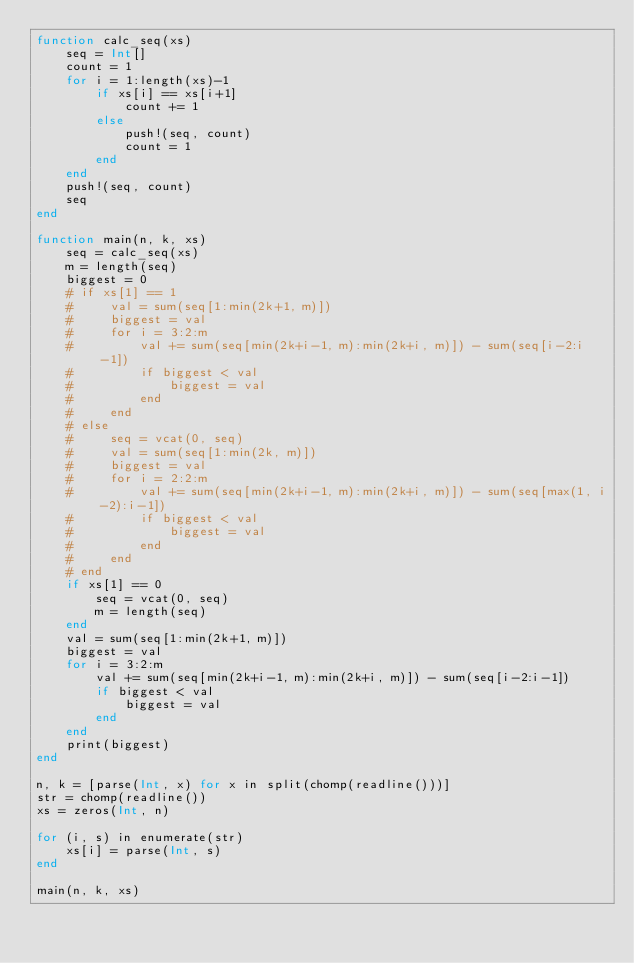Convert code to text. <code><loc_0><loc_0><loc_500><loc_500><_Julia_>function calc_seq(xs)
    seq = Int[]
    count = 1
    for i = 1:length(xs)-1
        if xs[i] == xs[i+1]
            count += 1
        else
            push!(seq, count)
            count = 1
        end
    end
    push!(seq, count)
    seq
end

function main(n, k, xs)
    seq = calc_seq(xs)
    m = length(seq)
    biggest = 0
    # if xs[1] == 1
    #     val = sum(seq[1:min(2k+1, m)])
    #     biggest = val
    #     for i = 3:2:m
    #         val += sum(seq[min(2k+i-1, m):min(2k+i, m)]) - sum(seq[i-2:i-1])
    #         if biggest < val
    #             biggest = val
    #         end
    #     end
    # else
    #     seq = vcat(0, seq)
    #     val = sum(seq[1:min(2k, m)])
    #     biggest = val
    #     for i = 2:2:m
    #         val += sum(seq[min(2k+i-1, m):min(2k+i, m)]) - sum(seq[max(1, i-2):i-1])
    #         if biggest < val
    #             biggest = val
    #         end
    #     end
    # end
    if xs[1] == 0
        seq = vcat(0, seq)
        m = length(seq)
    end
    val = sum(seq[1:min(2k+1, m)])
    biggest = val
    for i = 3:2:m
        val += sum(seq[min(2k+i-1, m):min(2k+i, m)]) - sum(seq[i-2:i-1])
        if biggest < val
            biggest = val
        end
    end
    print(biggest)
end

n, k = [parse(Int, x) for x in split(chomp(readline()))]
str = chomp(readline())
xs = zeros(Int, n)

for (i, s) in enumerate(str)
    xs[i] = parse(Int, s)
end

main(n, k, xs)</code> 